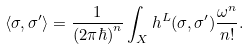Convert formula to latex. <formula><loc_0><loc_0><loc_500><loc_500>\langle \sigma , \sigma ^ { \prime } \rangle = \frac { 1 } { ( 2 \pi \hbar { ) } ^ { n } } \int _ { X } h ^ { L } ( \sigma , \sigma ^ { \prime } ) \frac { \omega ^ { n } } { n ! } .</formula> 